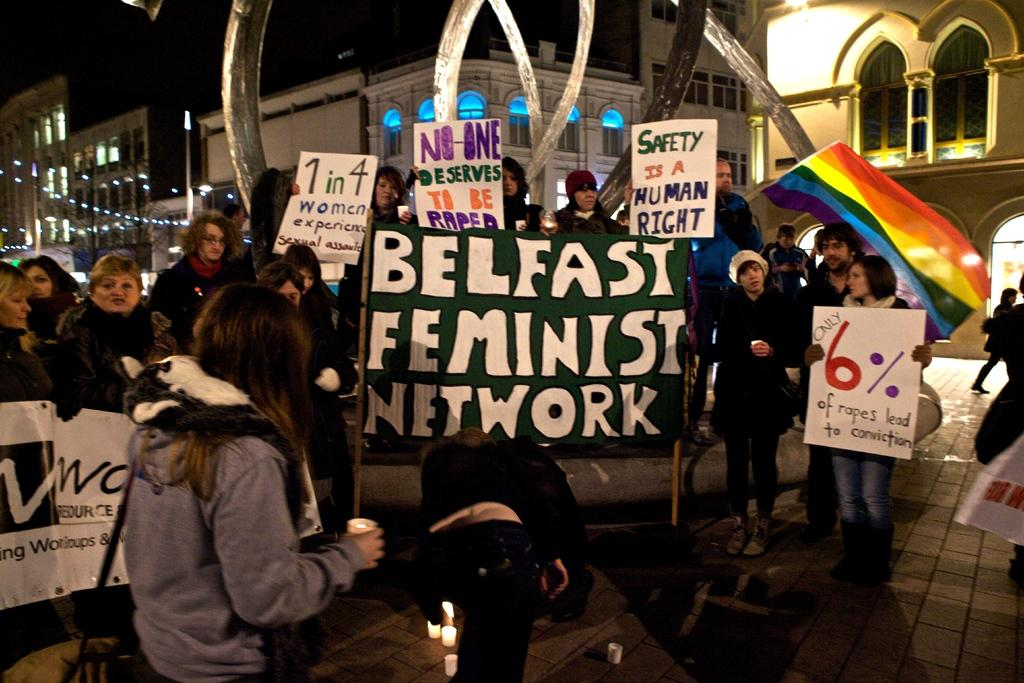How many people are in the group that is visible in the image? There is a group of people in the image, but the exact number is not specified. What are some people in the group holding? Some people in the group are holding banners and boards. What can be seen in the background of the image? There are buildings visible in the background of the image. Who is wearing the crown in the image? There is no crown present in the image. What type of canvas is being used by the people in the image? There is no canvas present in the image. 